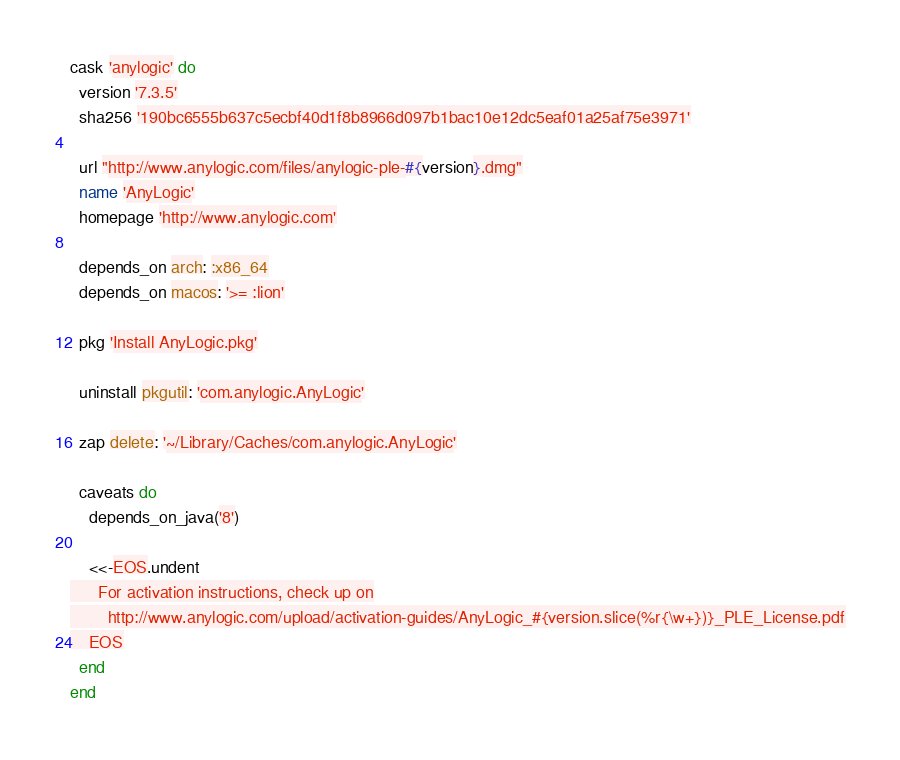Convert code to text. <code><loc_0><loc_0><loc_500><loc_500><_Ruby_>cask 'anylogic' do
  version '7.3.5'
  sha256 '190bc6555b637c5ecbf40d1f8b8966d097b1bac10e12dc5eaf01a25af75e3971'

  url "http://www.anylogic.com/files/anylogic-ple-#{version}.dmg"
  name 'AnyLogic'
  homepage 'http://www.anylogic.com'

  depends_on arch: :x86_64
  depends_on macos: '>= :lion'

  pkg 'Install AnyLogic.pkg'

  uninstall pkgutil: 'com.anylogic.AnyLogic'

  zap delete: '~/Library/Caches/com.anylogic.AnyLogic'

  caveats do
    depends_on_java('8')

    <<-EOS.undent
      For activation instructions, check up on
        http://www.anylogic.com/upload/activation-guides/AnyLogic_#{version.slice(%r{\w+})}_PLE_License.pdf
    EOS
  end
end
</code> 